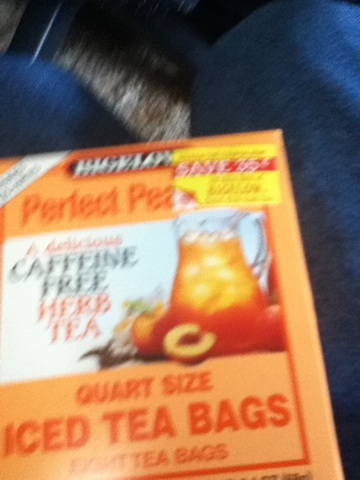Imagine this iced tea as a character in a story. What kind of adventures would it have? Perfect Peach, the refreshing hero, embarks on a quest to save the land from the scorching summer heat. Equipped with a magical pitcher that purifies and chills, Peach journeys through towns, bringing joy and cool relief to everyone. Along the way, Peach encounters evil caffeinated sorcerers trying to steal the peace of the land with their jittery spells. However, with the help of fruit fairies and herbal allies, Peach triumphs by spreading the magic of natural flavor and caffeine-free calmness. The tale of Perfect Peach is one of triumph, bringing harmonious bliss and refreshing rejuvenation wherever it goes. Can you link this character to a real-world scenario for a fun advertisement? Introducing Perfect Peach, your summer savior! When the sun blazes and tempers rise, Perfect Peach strides in with its cool, refreshing magic. Just one quart-sized tea bag will transform your ordinary pitcher into a delightful, peachy oasis. Say goodbye to caffeine jitters and hello to serene sips under the hottest sun! Perfect Peach: The hero your summer deserves! 